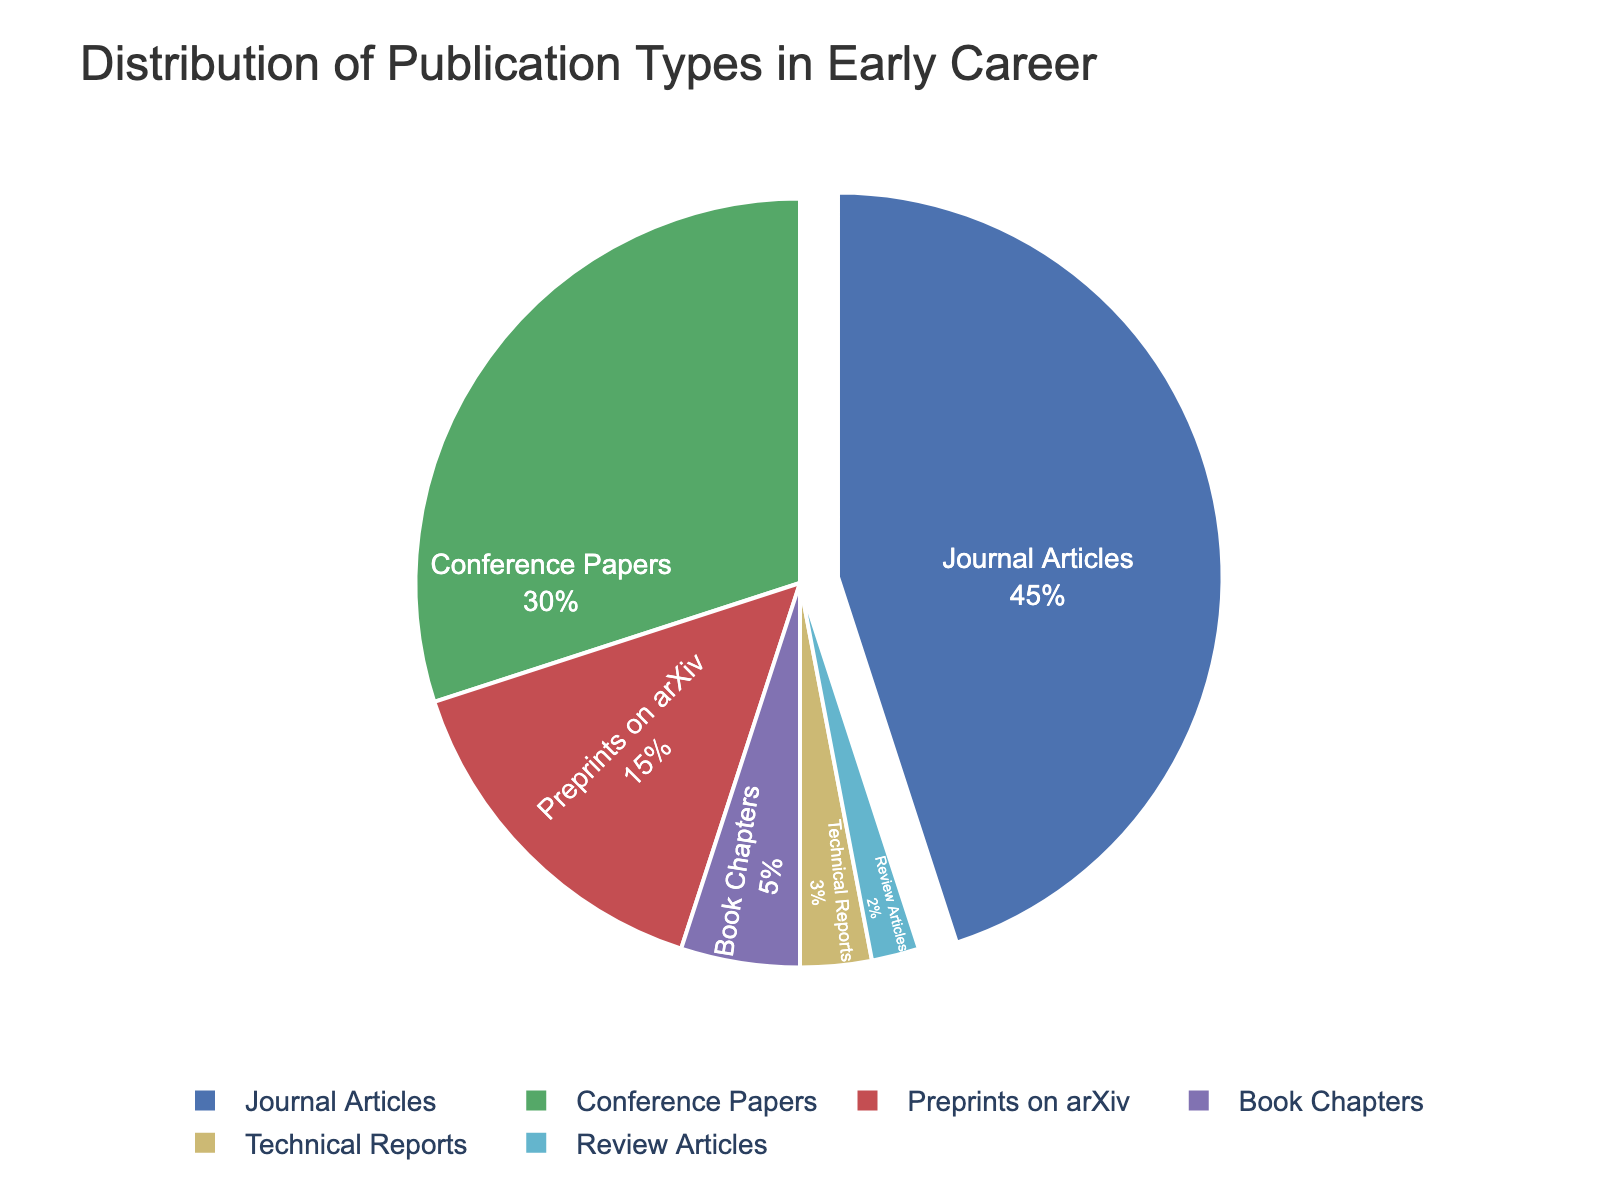What percentage of publication types are Journal Articles and Conference Papers together? To find this, sum the percentages of Journal Articles (45%) and Conference Papers (30%). Therefore, 45% + 30% = 75%.
Answer: 75% Which publication type has the smallest percentage? To find this, look at the percentages for all publication types and identify the smallest one. Review Articles have the smallest percentage at 2%.
Answer: Review Articles How much larger is the percentage of Journal Articles compared to Preprints on arXiv? Subtract the percentage of Preprints on arXiv (15%) from the percentage of Journal Articles (45%). Hence, 45% - 15% = 30%.
Answer: 30% What is the combined percentage of Book Chapters and Technical Reports? Sum the percentages of Book Chapters (5%) and Technical Reports (3%). So, 5% + 3% = 8%.
Answer: 8% How does the percentage of Conference Papers compare to that of Technical Reports? Observe the percentages of Conference Papers (30%) and Technical Reports (3%). Conference Papers are significantly higher.
Answer: Conference Papers are higher What percentage of publication types are not considered Journal Articles? To find this, subtract the percentage of Journal Articles (45%) from the total (100%). So, 100% - 45% = 55%.
Answer: 55% Which color represents Journal Articles in the pie chart? By looking at the color coding in the pie chart, Journal Articles are represented by the color blue, which is the first color in the custom palette used.
Answer: Blue Which publication types together make up less than 10% of the total? Summarize the percentages of publication types less than 10%, which are Technical Reports (3%) and Review Articles (2%). Together, they add up to 5%.
Answer: Technical Reports and Review Articles Is the percentage of Conference Papers more than double the percentage of Preprints on arXiv? Compare if 30% (Conference Papers) is more than double 15% (Preprints on arXiv). Because 2 * 15% = 30%, Conference Papers are exactly double.
Answer: No, it is not more than double but exactly double What is the average percentage of the least three represented publication types? Add the percentages of the least three publication types: Review Articles (2%), Technical Reports (3%), and Book Chapters (5%). Then divide the sum by 3. (2% + 3% + 5%) / 3 = 10% / 3 ≈ 3.33%.
Answer: 3.33% 